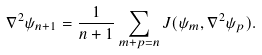<formula> <loc_0><loc_0><loc_500><loc_500>\nabla ^ { 2 } \psi _ { n + 1 } = \frac { 1 } { n + 1 } \sum _ { m + p = n } J ( \psi _ { m } , \nabla ^ { 2 } \psi _ { p } ) .</formula> 